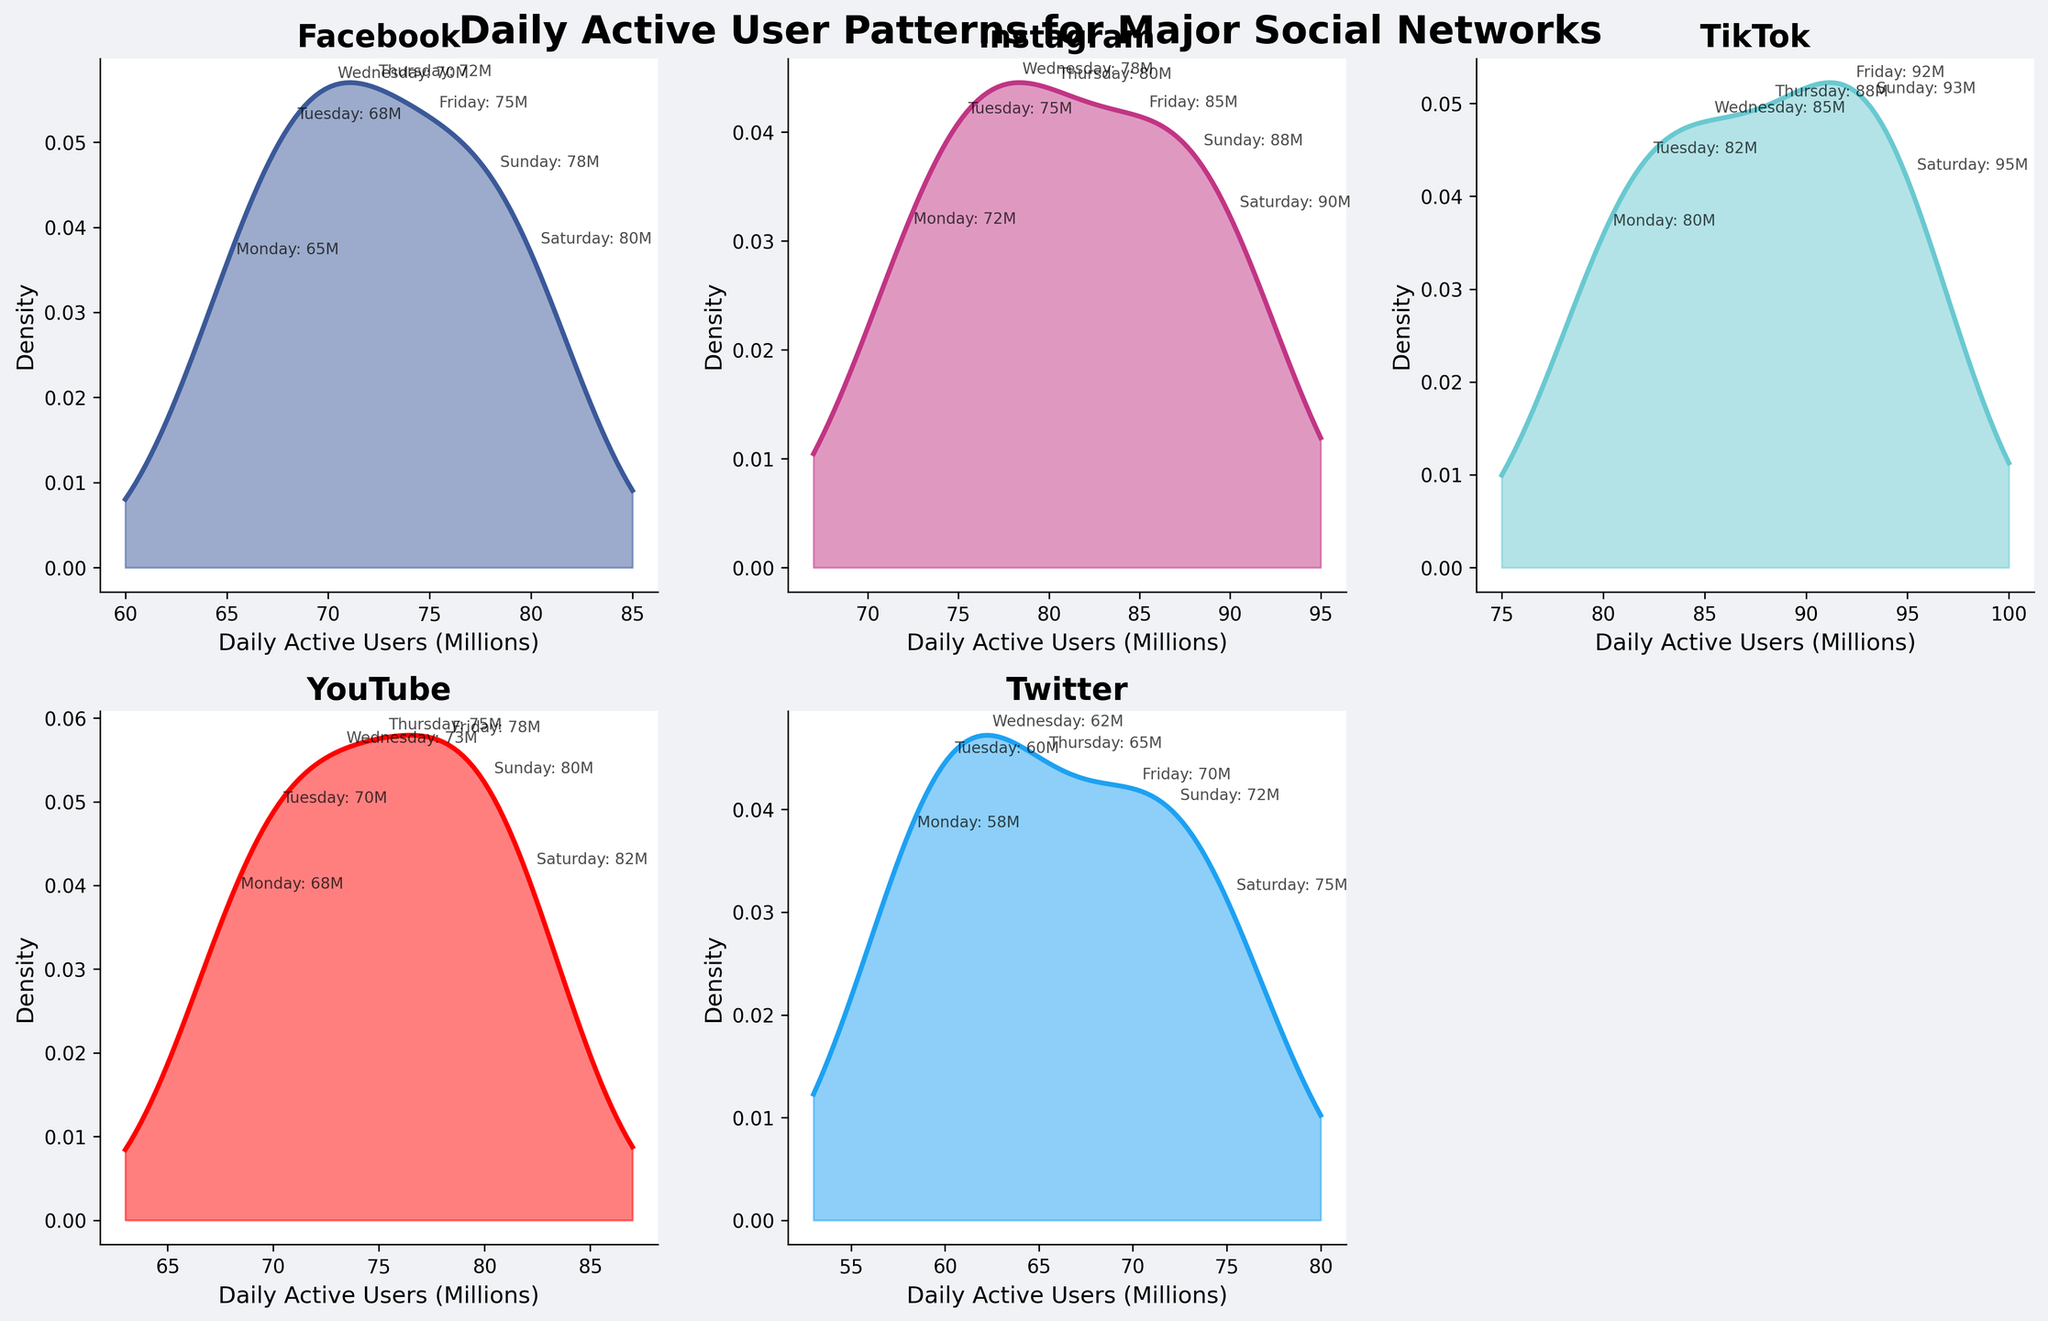What is the title of the figure? The title of the figure is found at the top and generally provides a concise description of what the figure represents. In this case, the title is bold and large, positioned at the top center of the figure.
Answer: Daily Active User Patterns for Major Social Networks Which social network has the highest peak density of daily active users? The peak density is indicated by the highest point on the density plot for each social network. Observing the plots, TikTok appears to have the highest peak density.
Answer: TikTok On which day does Facebook have the highest daily active users? By examining the daily labels on the Facebook plot, the highest value is marked on Saturday.
Answer: Saturday Between Instagram and Twitter, which network has a wider range of daily active users during the week? The range of daily active users can be assessed by looking at the spread of the density plots for the week on both Instagram and Twitter plots. Instagram's plot is wider, indicating a larger range of values.
Answer: Instagram Calculate the average daily active users for YouTube from Monday to Sunday. Sum the given daily values for YouTube and divide by the number of days: (68 + 70 + 73 + 75 + 78 + 82 + 80)/7. The result is 526/7.
Answer: 75.14 Comparing TikTok and Facebook, which network consistently has more daily active users throughout the week? By comparing the annotated values for each day across TikTok and Facebook panels, TikTok has higher daily active user values on every day of the week.
Answer: TikTok Which day shows the lowest density for Twitter's daily active users, and how can you tell? The lowest density will be indicated by the troughs or lowest points on the Twitter density plot. It appears that Monday has the lowest density since its value is the lowest.
Answer: Monday What's the most noticeable difference in the density plots between YouTube and Instagram? The most noticeable difference is in the peak and spread of the density plots. YouTube's peak is lower and has a narrower spread, whereas Instagram's peak is higher and the plot is more spread out.
Answer: Instagram has a higher peak and wider spread If we exclude Sunday, how does the density plot for Twitter change? Without Sunday's value, re-render the density plot and observe that the overall trend remains similar but the plot will likely slightly shift due to one less data point averaging into the density.
Answer: Slightly shifts but remains similar What is the trend of daily active users for Facebook throughout the week? Looking at the annotated values on the density plot for Facebook, the trend shows a steady increase from Monday leading up to and including Saturday, with a slight decrease on Sunday.
Answer: Increasing up to Saturday, slight decrease on Sunday 